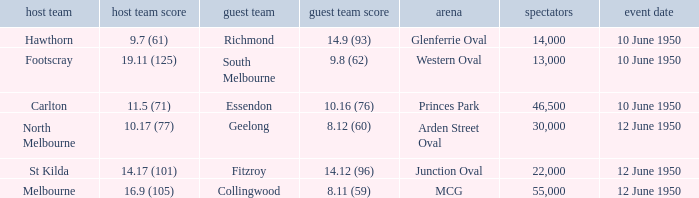Who was the away team when the VFL played at MCG? Collingwood. 